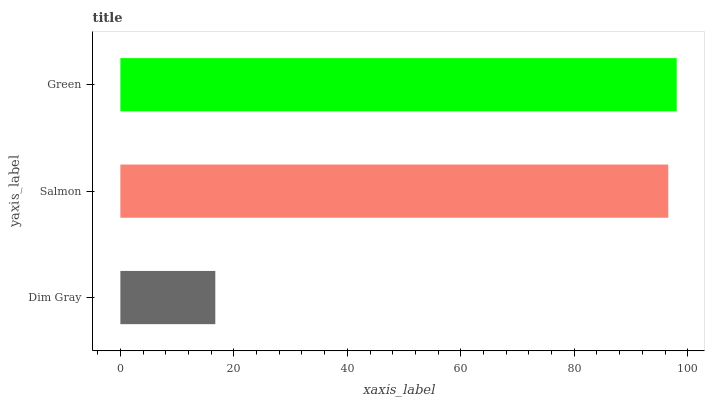Is Dim Gray the minimum?
Answer yes or no. Yes. Is Green the maximum?
Answer yes or no. Yes. Is Salmon the minimum?
Answer yes or no. No. Is Salmon the maximum?
Answer yes or no. No. Is Salmon greater than Dim Gray?
Answer yes or no. Yes. Is Dim Gray less than Salmon?
Answer yes or no. Yes. Is Dim Gray greater than Salmon?
Answer yes or no. No. Is Salmon less than Dim Gray?
Answer yes or no. No. Is Salmon the high median?
Answer yes or no. Yes. Is Salmon the low median?
Answer yes or no. Yes. Is Green the high median?
Answer yes or no. No. Is Dim Gray the low median?
Answer yes or no. No. 